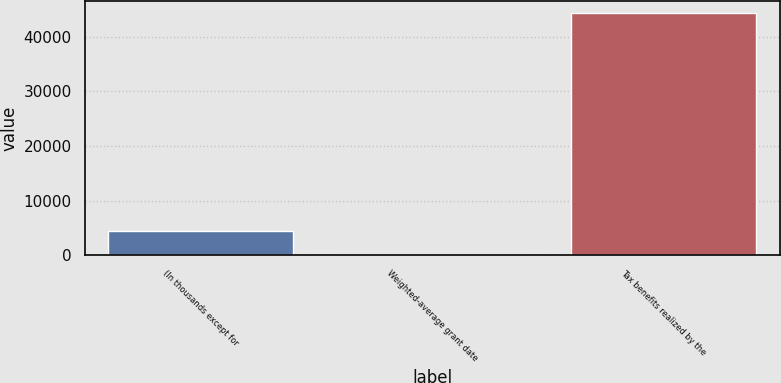<chart> <loc_0><loc_0><loc_500><loc_500><bar_chart><fcel>(In thousands except for<fcel>Weighted-average grant date<fcel>Tax benefits realized by the<nl><fcel>4477.75<fcel>53.28<fcel>44298<nl></chart> 